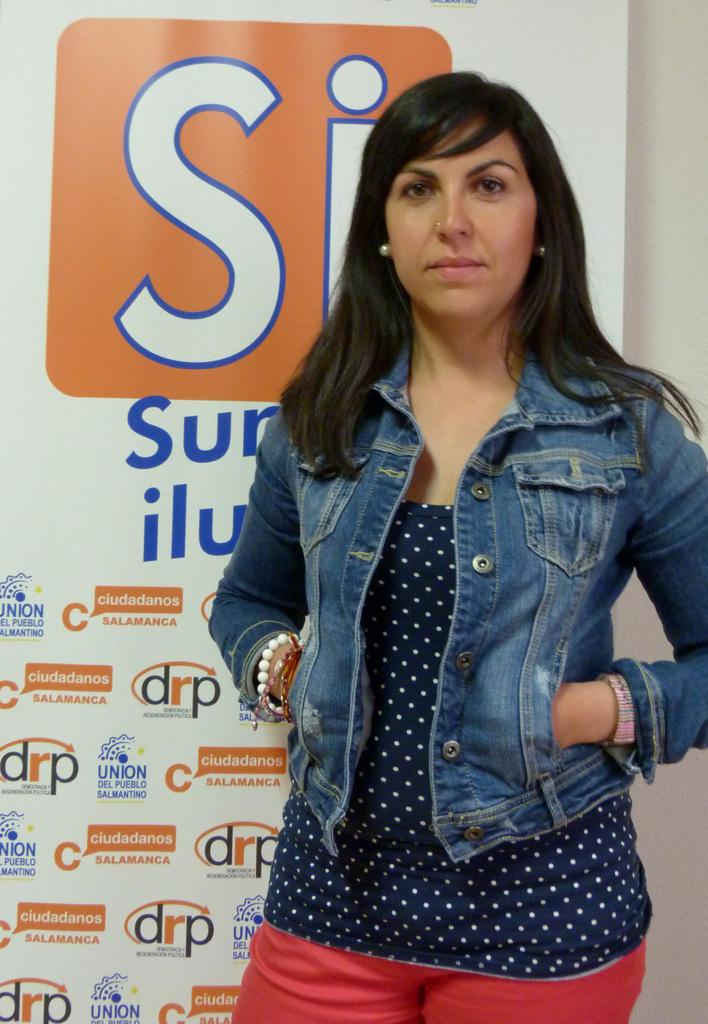What is the main subject in the image? There is a woman standing in the image. Can you describe the woman's position in the image? The woman is standing on the floor. What can be seen in the background of the image? There is an advertisement in the background of the image. What type of lace is the woman using to measure the distance between the two stitches in the image? There is no lace, measuring, or stitching present in the image. 